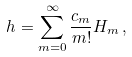<formula> <loc_0><loc_0><loc_500><loc_500>h = \sum _ { m = 0 } ^ { \infty } \frac { c _ { m } } { m ! } H _ { m } \, ,</formula> 